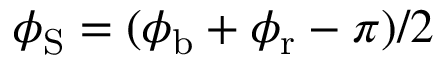<formula> <loc_0><loc_0><loc_500><loc_500>\phi _ { S } = ( \phi _ { b } + \phi _ { r } - \pi ) / 2</formula> 